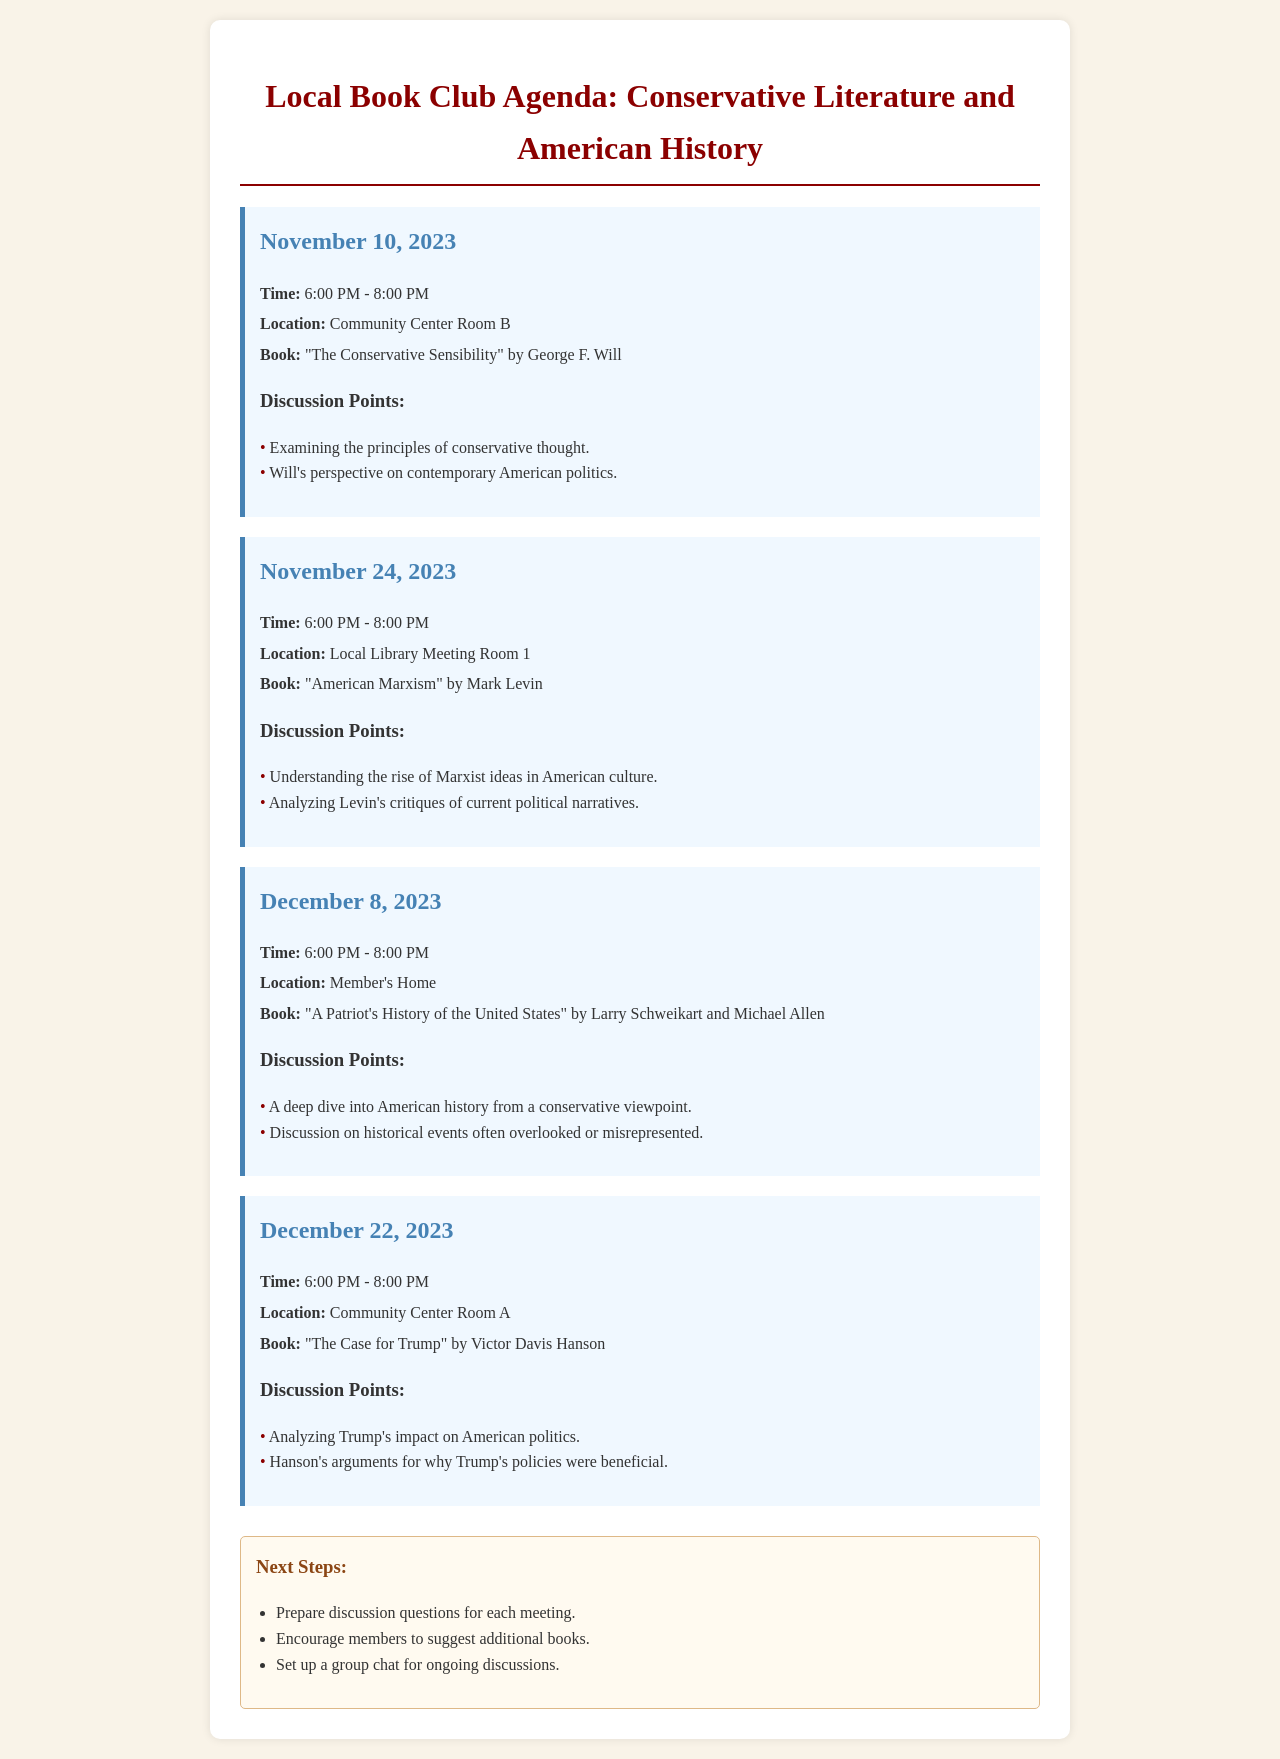What is the date of the first meeting? The first meeting is scheduled for November 10, 2023.
Answer: November 10, 2023 What book will be discussed on November 24, 2023? The book for discussion on that date is "American Marxism" by Mark Levin.
Answer: "American Marxism" by Mark Levin Where will the December 8, 2023 meeting take place? The meeting on that date will be held at a member's home.
Answer: Member's Home What are the discussion points for the meeting on December 22, 2023? The discussion points are analyzing Trump's impact and Hanson's arguments.
Answer: Analyzing Trump's impact on American politics; Hanson’s arguments for why Trump's policies were beneficial When is the last meeting scheduled? The last meeting is scheduled for December 22, 2023.
Answer: December 22, 2023 What book will be discussed at the December 8, 2023 meeting? The book to be discussed is "A Patriot's History of the United States" by Larry Schweikart and Michael Allen.
Answer: "A Patriot's History of the United States" by Larry Schweikart and Michael Allen 